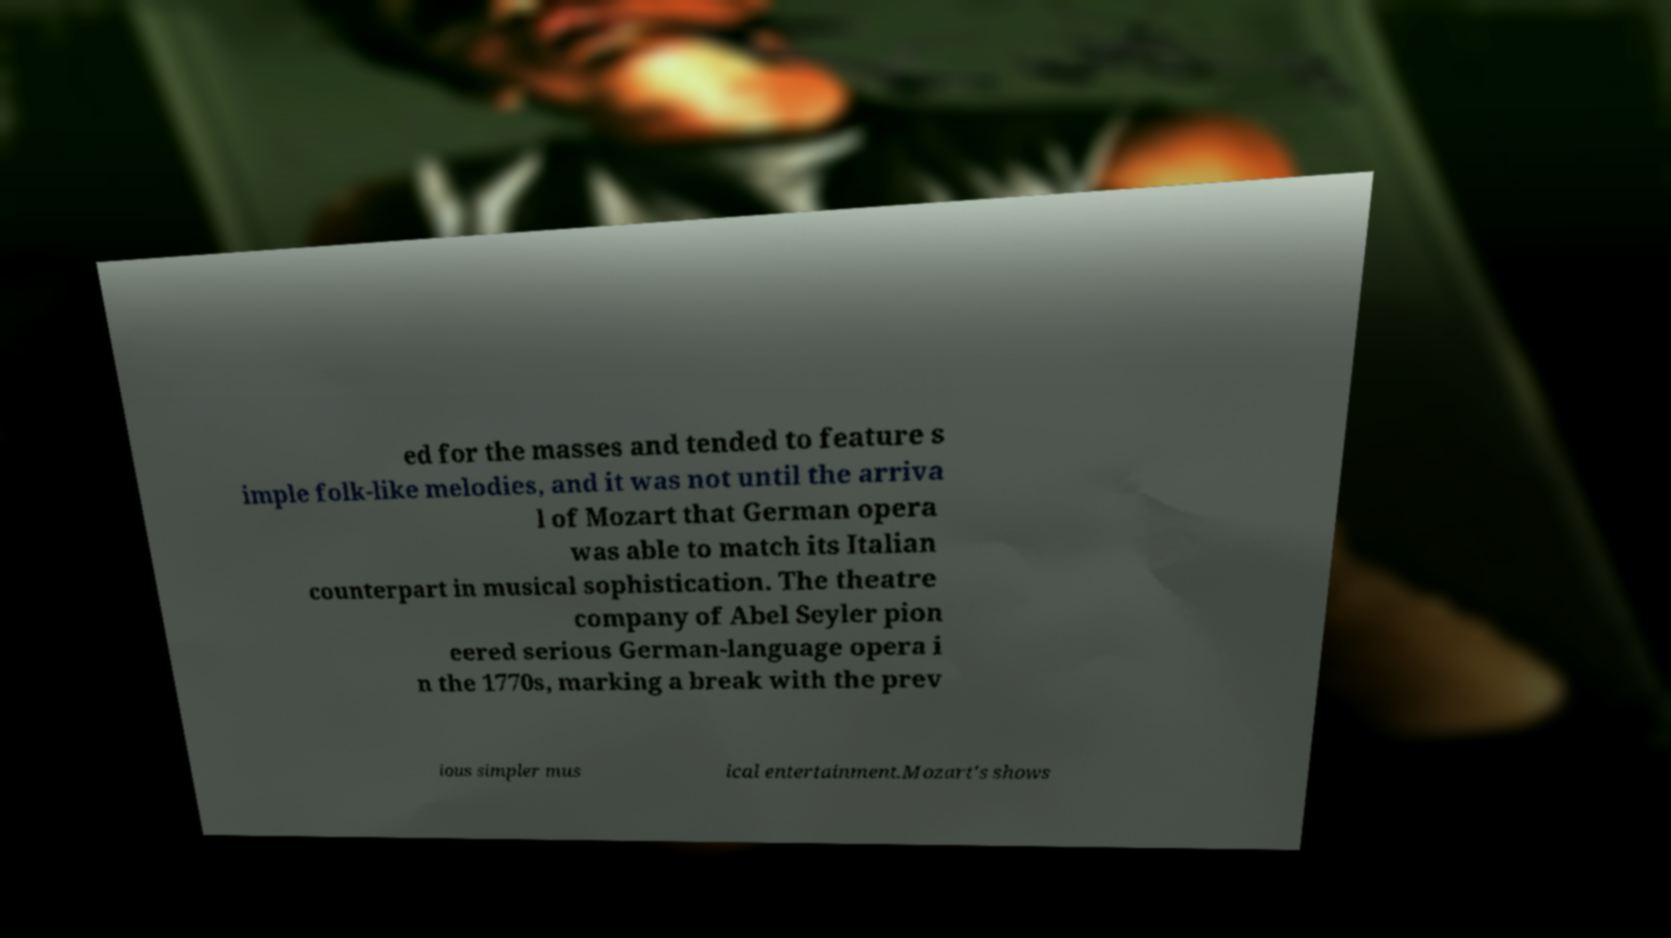Please read and relay the text visible in this image. What does it say? ed for the masses and tended to feature s imple folk-like melodies, and it was not until the arriva l of Mozart that German opera was able to match its Italian counterpart in musical sophistication. The theatre company of Abel Seyler pion eered serious German-language opera i n the 1770s, marking a break with the prev ious simpler mus ical entertainment.Mozart's shows 